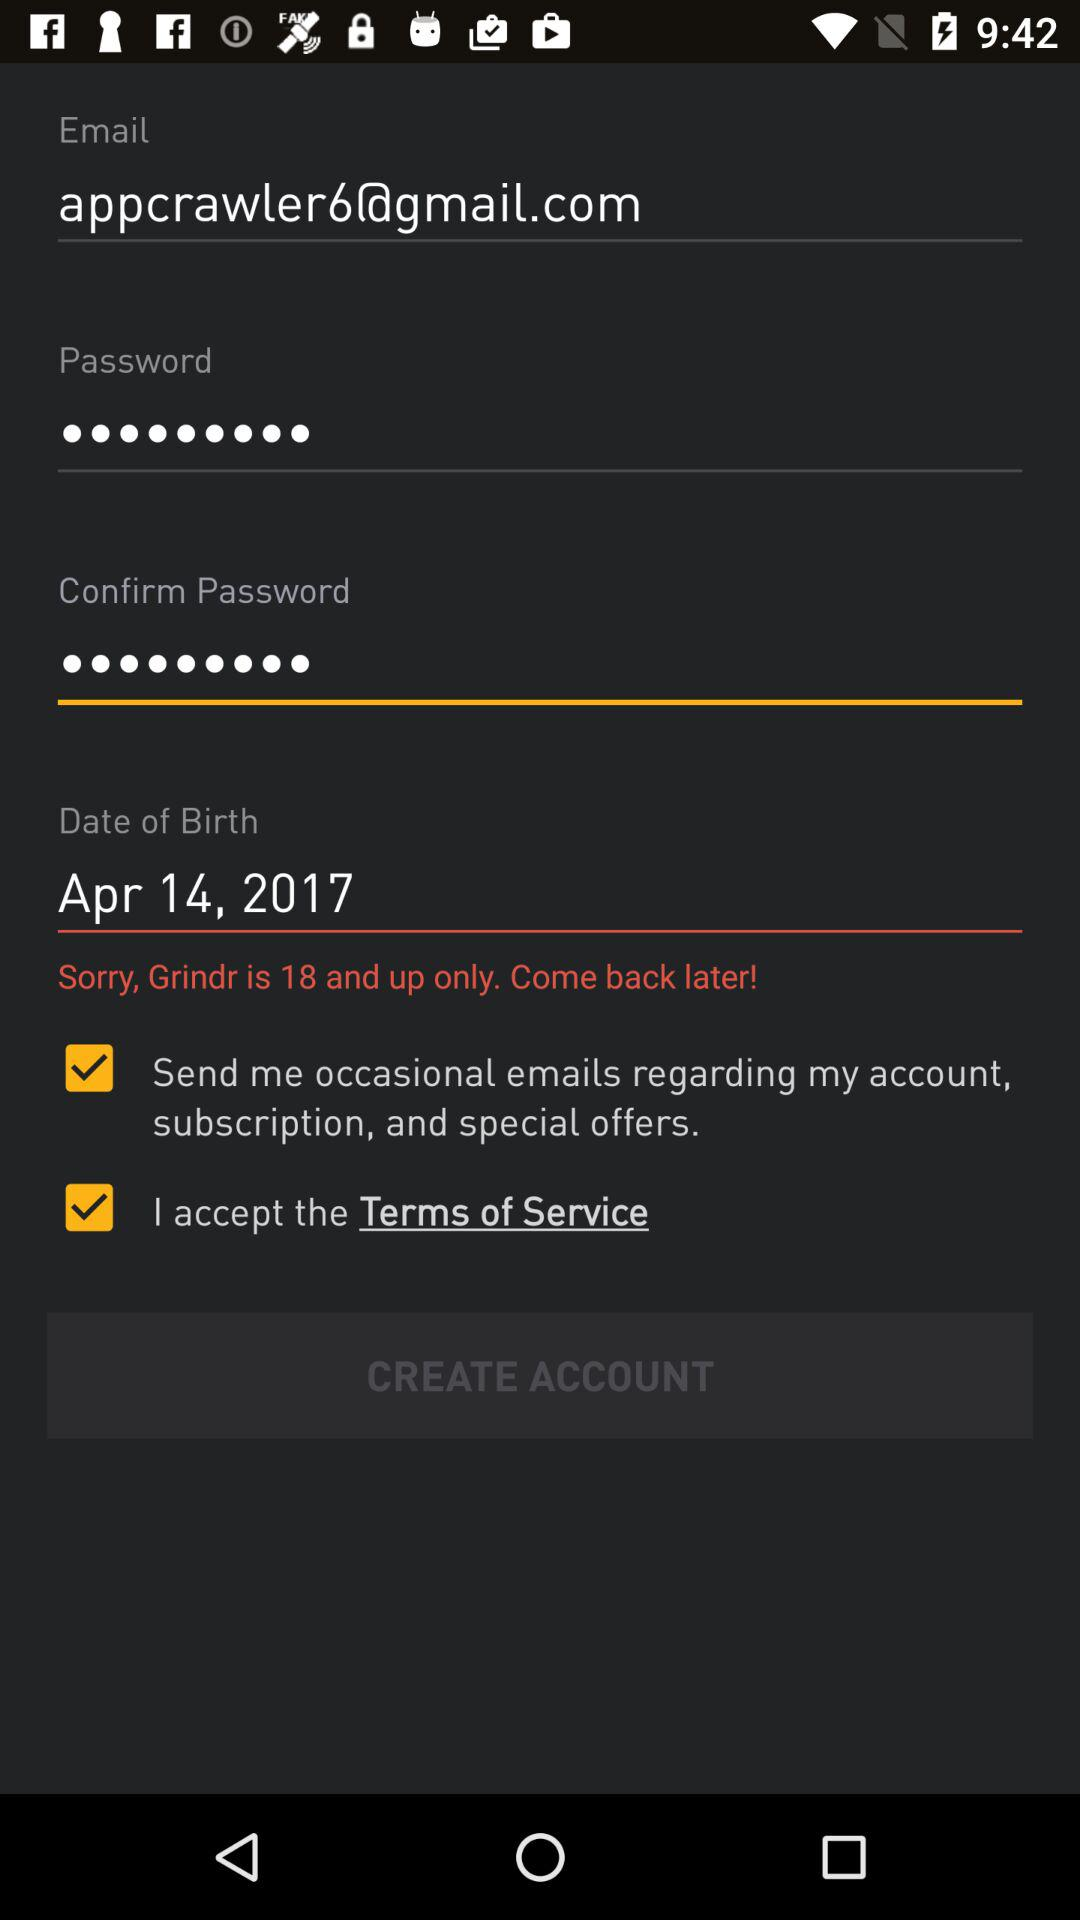What is the required minimum age? The required minimum age is 18. 